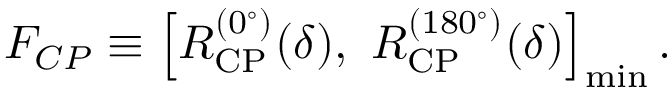Convert formula to latex. <formula><loc_0><loc_0><loc_500><loc_500>F _ { C P } \equiv \left [ R _ { C P } ^ { ( 0 ^ { \circ } ) } ( \delta ) , R _ { C P } ^ { ( 1 8 0 ^ { \circ } ) } ( \delta ) \right ] _ { \min } .</formula> 